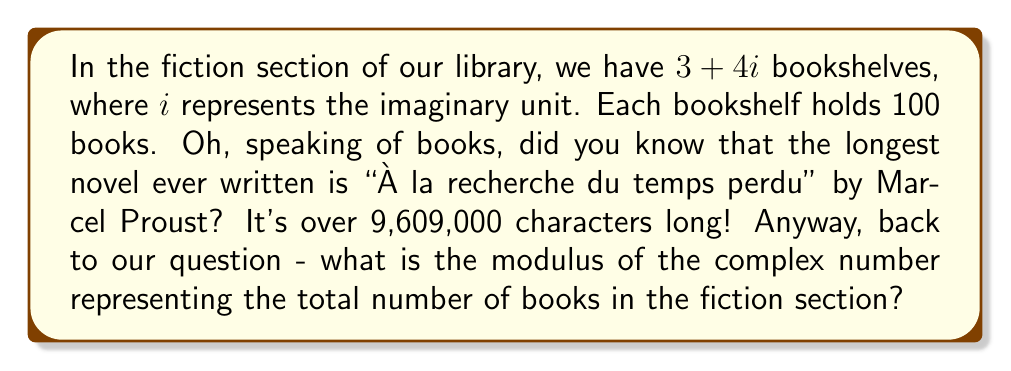Help me with this question. Let's approach this step-by-step:

1) First, we need to understand what the complex number $3 + 4i$ represents in this context:
   - The real part (3) represents the number of "regular" bookshelves
   - The imaginary part (4) represents the number of "special" bookshelves

2) Each bookshelf, regardless of type, holds 100 books. So we need to multiply our complex number by 100:
   $$(3 + 4i) \times 100 = 300 + 400i$$

3) Now, we have a complex number $300 + 400i$ representing the total number of books.

4) To find the modulus of a complex number $a + bi$, we use the formula:
   $$|a + bi| = \sqrt{a^2 + b^2}$$

5) In our case, $a = 300$ and $b = 400$. Let's substitute these values:
   $$|300 + 400i| = \sqrt{300^2 + 400^2}$$

6) Now let's calculate:
   $$\sqrt{300^2 + 400^2} = \sqrt{90,000 + 160,000} = \sqrt{250,000} = 500$$

Therefore, the modulus of the complex number representing the total number of books is 500.
Answer: 500 